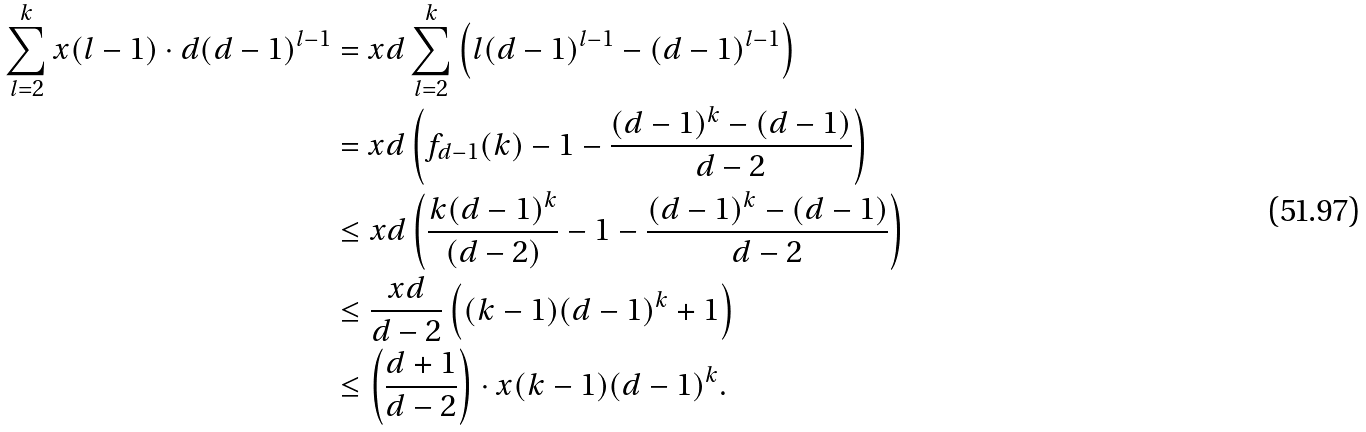Convert formula to latex. <formula><loc_0><loc_0><loc_500><loc_500>\sum _ { l = 2 } ^ { k } x ( l - 1 ) \cdot d ( d - 1 ) ^ { l - 1 } & = x d \sum _ { l = 2 } ^ { k } \left ( l ( d - 1 ) ^ { l - 1 } - ( d - 1 ) ^ { l - 1 } \right ) \\ & = x d \left ( f _ { d - 1 } ( k ) - 1 - \frac { ( d - 1 ) ^ { k } - ( d - 1 ) } { d - 2 } \right ) \\ & \leq x d \left ( \frac { k ( d - 1 ) ^ { k } } { ( d - 2 ) } - 1 - \frac { ( d - 1 ) ^ { k } - ( d - 1 ) } { d - 2 } \right ) \\ & \leq \frac { x d } { d - 2 } \left ( ( k - 1 ) ( d - 1 ) ^ { k } + 1 \right ) \\ & \leq \left ( \frac { d + 1 } { d - 2 } \right ) \cdot x ( k - 1 ) ( d - 1 ) ^ { k } .</formula> 